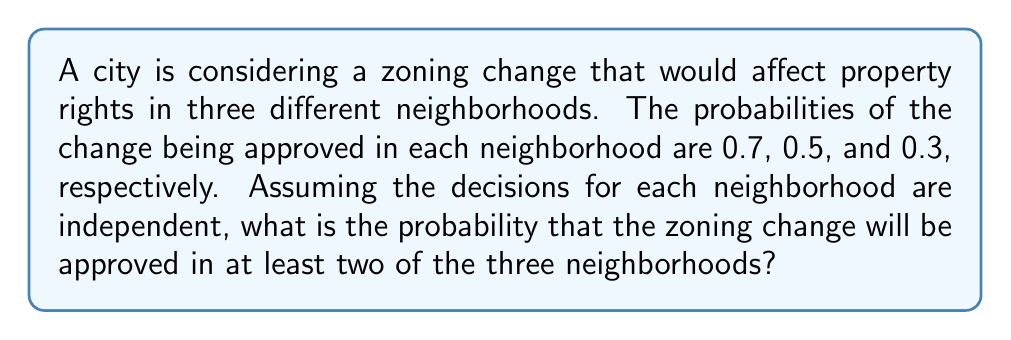Provide a solution to this math problem. Let's approach this step-by-step using probability theory:

1) First, let's define our events:
   A: Zoning change approved in neighborhood 1 (P(A) = 0.7)
   B: Zoning change approved in neighborhood 2 (P(B) = 0.5)
   C: Zoning change approved in neighborhood 3 (P(C) = 0.3)

2) We want to find the probability of the change being approved in at least two neighborhoods. This is equivalent to the probability of it being approved in:
   - All three neighborhoods, OR
   - Exactly two neighborhoods

3) Let's calculate these probabilities:

   P(All three) = P(A ∩ B ∩ C) = 0.7 × 0.5 × 0.3 = 0.105

   P(Exactly two) = P(A ∩ B ∩ C') + P(A ∩ B' ∩ C) + P(A' ∩ B ∩ C)
                  = (0.7 × 0.5 × 0.7) + (0.7 × 0.5 × 0.3) + (0.3 × 0.5 × 0.3)
                  = 0.245 + 0.105 + 0.045
                  = 0.395

4) The probability of at least two is the sum of these probabilities:

   P(At least two) = P(All three) + P(Exactly two)
                   = 0.105 + 0.395
                   = 0.5

5) Therefore, the probability of the zoning change being approved in at least two of the three neighborhoods is 0.5 or 50%.
Answer: 0.5 